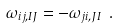<formula> <loc_0><loc_0><loc_500><loc_500>\omega _ { i j , I J } = - \omega _ { j i , J I } \ .</formula> 